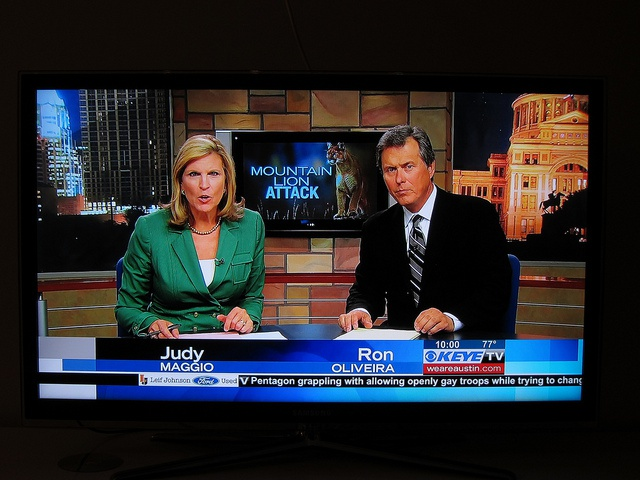Describe the objects in this image and their specific colors. I can see people in black, salmon, and gray tones, people in black, teal, and darkgreen tones, tv in black, navy, gray, and darkblue tones, and tie in black, gray, darkgray, and lightgray tones in this image. 